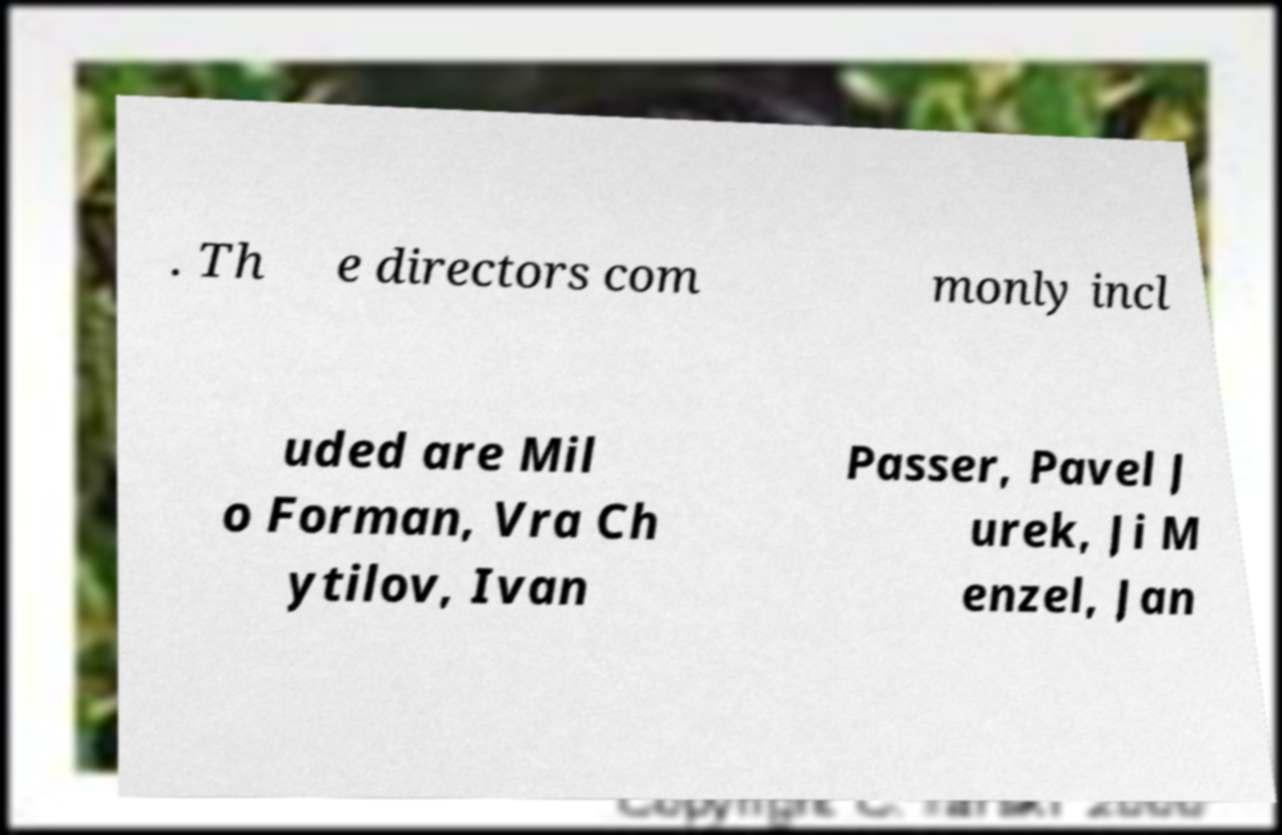Please read and relay the text visible in this image. What does it say? . Th e directors com monly incl uded are Mil o Forman, Vra Ch ytilov, Ivan Passer, Pavel J urek, Ji M enzel, Jan 